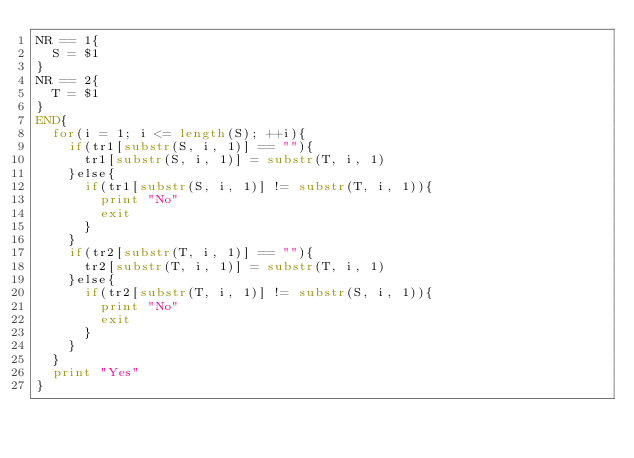Convert code to text. <code><loc_0><loc_0><loc_500><loc_500><_Awk_>NR == 1{
  S = $1
}
NR == 2{
  T = $1
}
END{
  for(i = 1; i <= length(S); ++i){
    if(tr1[substr(S, i, 1)] == ""){
      tr1[substr(S, i, 1)] = substr(T, i, 1)
    }else{
      if(tr1[substr(S, i, 1)] != substr(T, i, 1)){
        print "No"
        exit
      }
    }
    if(tr2[substr(T, i, 1)] == ""){
      tr2[substr(T, i, 1)] = substr(T, i, 1)
    }else{
      if(tr2[substr(T, i, 1)] != substr(S, i, 1)){
        print "No"
        exit
      }
    }
  }
  print "Yes"
}</code> 